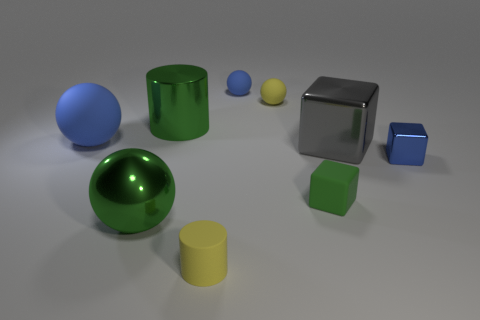What materials do the objects in the image appear to be made of? The objects in the image seem to have various materials. The spheres and cylinders look like they could be made of a glossy type of plastic due to their reflective surfaces. Meanwhile, the cube has a metallic sheen, suggesting it could be made of metal. 